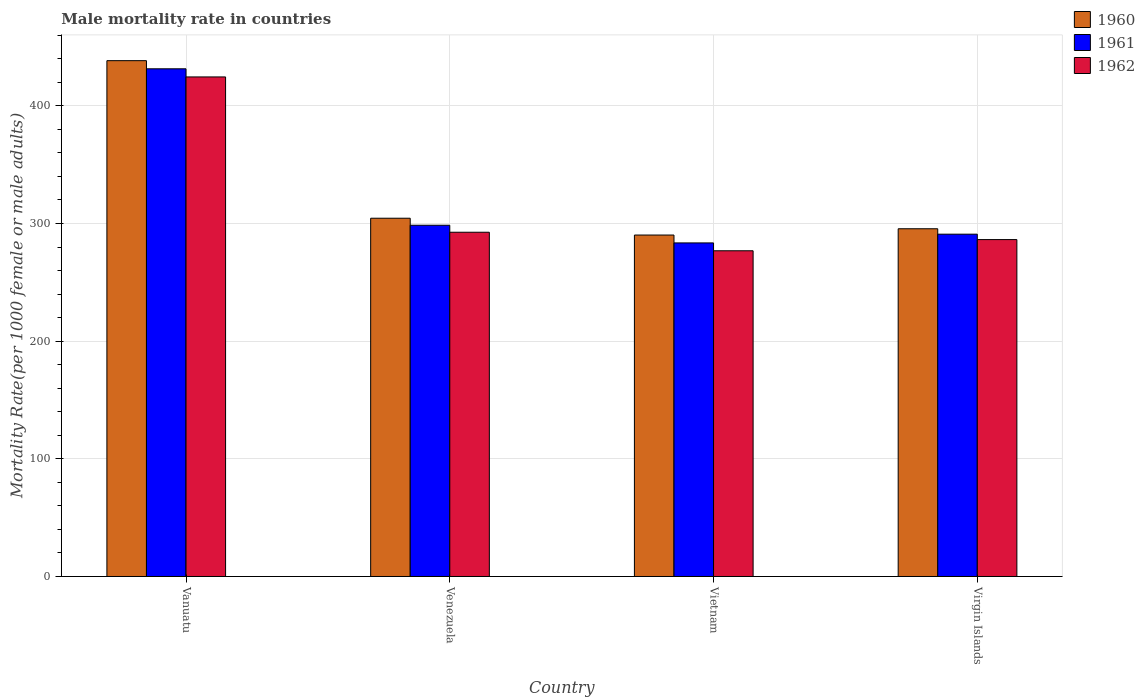How many groups of bars are there?
Ensure brevity in your answer.  4. Are the number of bars on each tick of the X-axis equal?
Your response must be concise. Yes. How many bars are there on the 1st tick from the left?
Provide a short and direct response. 3. How many bars are there on the 1st tick from the right?
Provide a short and direct response. 3. What is the label of the 1st group of bars from the left?
Your answer should be compact. Vanuatu. In how many cases, is the number of bars for a given country not equal to the number of legend labels?
Keep it short and to the point. 0. What is the male mortality rate in 1961 in Vietnam?
Offer a terse response. 283.51. Across all countries, what is the maximum male mortality rate in 1961?
Your response must be concise. 431.48. Across all countries, what is the minimum male mortality rate in 1961?
Make the answer very short. 283.51. In which country was the male mortality rate in 1962 maximum?
Give a very brief answer. Vanuatu. In which country was the male mortality rate in 1960 minimum?
Keep it short and to the point. Vietnam. What is the total male mortality rate in 1960 in the graph?
Make the answer very short. 1328.61. What is the difference between the male mortality rate in 1960 in Venezuela and that in Virgin Islands?
Your answer should be compact. 8.95. What is the difference between the male mortality rate in 1960 in Venezuela and the male mortality rate in 1962 in Vietnam?
Give a very brief answer. 27.66. What is the average male mortality rate in 1961 per country?
Your answer should be compact. 326.11. What is the difference between the male mortality rate of/in 1961 and male mortality rate of/in 1960 in Vietnam?
Offer a terse response. -6.69. In how many countries, is the male mortality rate in 1961 greater than 240?
Provide a succinct answer. 4. What is the ratio of the male mortality rate in 1962 in Vanuatu to that in Venezuela?
Your answer should be very brief. 1.45. Is the male mortality rate in 1960 in Vietnam less than that in Virgin Islands?
Ensure brevity in your answer.  Yes. What is the difference between the highest and the second highest male mortality rate in 1960?
Make the answer very short. -133.91. What is the difference between the highest and the lowest male mortality rate in 1960?
Keep it short and to the point. 148.2. In how many countries, is the male mortality rate in 1961 greater than the average male mortality rate in 1961 taken over all countries?
Ensure brevity in your answer.  1. What does the 3rd bar from the left in Venezuela represents?
Make the answer very short. 1962. What does the 3rd bar from the right in Venezuela represents?
Provide a short and direct response. 1960. What is the difference between two consecutive major ticks on the Y-axis?
Your answer should be compact. 100. Does the graph contain any zero values?
Make the answer very short. No. Where does the legend appear in the graph?
Provide a succinct answer. Top right. How many legend labels are there?
Offer a terse response. 3. How are the legend labels stacked?
Keep it short and to the point. Vertical. What is the title of the graph?
Provide a succinct answer. Male mortality rate in countries. Does "2013" appear as one of the legend labels in the graph?
Provide a short and direct response. No. What is the label or title of the X-axis?
Give a very brief answer. Country. What is the label or title of the Y-axis?
Ensure brevity in your answer.  Mortality Rate(per 1000 female or male adults). What is the Mortality Rate(per 1000 female or male adults) of 1960 in Vanuatu?
Provide a succinct answer. 438.4. What is the Mortality Rate(per 1000 female or male adults) in 1961 in Vanuatu?
Your response must be concise. 431.48. What is the Mortality Rate(per 1000 female or male adults) of 1962 in Vanuatu?
Give a very brief answer. 424.57. What is the Mortality Rate(per 1000 female or male adults) of 1960 in Venezuela?
Give a very brief answer. 304.49. What is the Mortality Rate(per 1000 female or male adults) in 1961 in Venezuela?
Give a very brief answer. 298.53. What is the Mortality Rate(per 1000 female or male adults) in 1962 in Venezuela?
Give a very brief answer. 292.57. What is the Mortality Rate(per 1000 female or male adults) of 1960 in Vietnam?
Your answer should be compact. 290.19. What is the Mortality Rate(per 1000 female or male adults) in 1961 in Vietnam?
Offer a terse response. 283.51. What is the Mortality Rate(per 1000 female or male adults) in 1962 in Vietnam?
Your answer should be very brief. 276.82. What is the Mortality Rate(per 1000 female or male adults) of 1960 in Virgin Islands?
Provide a short and direct response. 295.53. What is the Mortality Rate(per 1000 female or male adults) of 1961 in Virgin Islands?
Give a very brief answer. 290.94. What is the Mortality Rate(per 1000 female or male adults) of 1962 in Virgin Islands?
Keep it short and to the point. 286.34. Across all countries, what is the maximum Mortality Rate(per 1000 female or male adults) of 1960?
Give a very brief answer. 438.4. Across all countries, what is the maximum Mortality Rate(per 1000 female or male adults) of 1961?
Your answer should be very brief. 431.48. Across all countries, what is the maximum Mortality Rate(per 1000 female or male adults) in 1962?
Make the answer very short. 424.57. Across all countries, what is the minimum Mortality Rate(per 1000 female or male adults) of 1960?
Your response must be concise. 290.19. Across all countries, what is the minimum Mortality Rate(per 1000 female or male adults) in 1961?
Keep it short and to the point. 283.51. Across all countries, what is the minimum Mortality Rate(per 1000 female or male adults) of 1962?
Your answer should be very brief. 276.82. What is the total Mortality Rate(per 1000 female or male adults) in 1960 in the graph?
Your answer should be very brief. 1328.61. What is the total Mortality Rate(per 1000 female or male adults) in 1961 in the graph?
Keep it short and to the point. 1304.46. What is the total Mortality Rate(per 1000 female or male adults) in 1962 in the graph?
Make the answer very short. 1280.3. What is the difference between the Mortality Rate(per 1000 female or male adults) of 1960 in Vanuatu and that in Venezuela?
Make the answer very short. 133.91. What is the difference between the Mortality Rate(per 1000 female or male adults) of 1961 in Vanuatu and that in Venezuela?
Offer a terse response. 132.96. What is the difference between the Mortality Rate(per 1000 female or male adults) in 1962 in Vanuatu and that in Venezuela?
Provide a succinct answer. 132. What is the difference between the Mortality Rate(per 1000 female or male adults) in 1960 in Vanuatu and that in Vietnam?
Offer a very short reply. 148.2. What is the difference between the Mortality Rate(per 1000 female or male adults) of 1961 in Vanuatu and that in Vietnam?
Give a very brief answer. 147.97. What is the difference between the Mortality Rate(per 1000 female or male adults) in 1962 in Vanuatu and that in Vietnam?
Offer a very short reply. 147.75. What is the difference between the Mortality Rate(per 1000 female or male adults) in 1960 in Vanuatu and that in Virgin Islands?
Provide a succinct answer. 142.86. What is the difference between the Mortality Rate(per 1000 female or male adults) of 1961 in Vanuatu and that in Virgin Islands?
Give a very brief answer. 140.55. What is the difference between the Mortality Rate(per 1000 female or male adults) in 1962 in Vanuatu and that in Virgin Islands?
Make the answer very short. 138.23. What is the difference between the Mortality Rate(per 1000 female or male adults) in 1960 in Venezuela and that in Vietnam?
Your response must be concise. 14.29. What is the difference between the Mortality Rate(per 1000 female or male adults) of 1961 in Venezuela and that in Vietnam?
Give a very brief answer. 15.02. What is the difference between the Mortality Rate(per 1000 female or male adults) of 1962 in Venezuela and that in Vietnam?
Ensure brevity in your answer.  15.74. What is the difference between the Mortality Rate(per 1000 female or male adults) in 1960 in Venezuela and that in Virgin Islands?
Give a very brief answer. 8.95. What is the difference between the Mortality Rate(per 1000 female or male adults) in 1961 in Venezuela and that in Virgin Islands?
Keep it short and to the point. 7.59. What is the difference between the Mortality Rate(per 1000 female or male adults) of 1962 in Venezuela and that in Virgin Islands?
Offer a very short reply. 6.23. What is the difference between the Mortality Rate(per 1000 female or male adults) of 1960 in Vietnam and that in Virgin Islands?
Give a very brief answer. -5.34. What is the difference between the Mortality Rate(per 1000 female or male adults) of 1961 in Vietnam and that in Virgin Islands?
Offer a terse response. -7.43. What is the difference between the Mortality Rate(per 1000 female or male adults) in 1962 in Vietnam and that in Virgin Islands?
Provide a short and direct response. -9.51. What is the difference between the Mortality Rate(per 1000 female or male adults) in 1960 in Vanuatu and the Mortality Rate(per 1000 female or male adults) in 1961 in Venezuela?
Give a very brief answer. 139.87. What is the difference between the Mortality Rate(per 1000 female or male adults) in 1960 in Vanuatu and the Mortality Rate(per 1000 female or male adults) in 1962 in Venezuela?
Give a very brief answer. 145.83. What is the difference between the Mortality Rate(per 1000 female or male adults) in 1961 in Vanuatu and the Mortality Rate(per 1000 female or male adults) in 1962 in Venezuela?
Make the answer very short. 138.91. What is the difference between the Mortality Rate(per 1000 female or male adults) of 1960 in Vanuatu and the Mortality Rate(per 1000 female or male adults) of 1961 in Vietnam?
Your response must be concise. 154.89. What is the difference between the Mortality Rate(per 1000 female or male adults) in 1960 in Vanuatu and the Mortality Rate(per 1000 female or male adults) in 1962 in Vietnam?
Your response must be concise. 161.57. What is the difference between the Mortality Rate(per 1000 female or male adults) in 1961 in Vanuatu and the Mortality Rate(per 1000 female or male adults) in 1962 in Vietnam?
Provide a short and direct response. 154.66. What is the difference between the Mortality Rate(per 1000 female or male adults) of 1960 in Vanuatu and the Mortality Rate(per 1000 female or male adults) of 1961 in Virgin Islands?
Ensure brevity in your answer.  147.46. What is the difference between the Mortality Rate(per 1000 female or male adults) in 1960 in Vanuatu and the Mortality Rate(per 1000 female or male adults) in 1962 in Virgin Islands?
Your response must be concise. 152.06. What is the difference between the Mortality Rate(per 1000 female or male adults) in 1961 in Vanuatu and the Mortality Rate(per 1000 female or male adults) in 1962 in Virgin Islands?
Make the answer very short. 145.15. What is the difference between the Mortality Rate(per 1000 female or male adults) in 1960 in Venezuela and the Mortality Rate(per 1000 female or male adults) in 1961 in Vietnam?
Ensure brevity in your answer.  20.98. What is the difference between the Mortality Rate(per 1000 female or male adults) of 1960 in Venezuela and the Mortality Rate(per 1000 female or male adults) of 1962 in Vietnam?
Your answer should be compact. 27.66. What is the difference between the Mortality Rate(per 1000 female or male adults) in 1961 in Venezuela and the Mortality Rate(per 1000 female or male adults) in 1962 in Vietnam?
Give a very brief answer. 21.7. What is the difference between the Mortality Rate(per 1000 female or male adults) of 1960 in Venezuela and the Mortality Rate(per 1000 female or male adults) of 1961 in Virgin Islands?
Your answer should be compact. 13.55. What is the difference between the Mortality Rate(per 1000 female or male adults) of 1960 in Venezuela and the Mortality Rate(per 1000 female or male adults) of 1962 in Virgin Islands?
Provide a short and direct response. 18.15. What is the difference between the Mortality Rate(per 1000 female or male adults) in 1961 in Venezuela and the Mortality Rate(per 1000 female or male adults) in 1962 in Virgin Islands?
Provide a succinct answer. 12.19. What is the difference between the Mortality Rate(per 1000 female or male adults) of 1960 in Vietnam and the Mortality Rate(per 1000 female or male adults) of 1961 in Virgin Islands?
Provide a short and direct response. -0.74. What is the difference between the Mortality Rate(per 1000 female or male adults) of 1960 in Vietnam and the Mortality Rate(per 1000 female or male adults) of 1962 in Virgin Islands?
Offer a very short reply. 3.86. What is the difference between the Mortality Rate(per 1000 female or male adults) in 1961 in Vietnam and the Mortality Rate(per 1000 female or male adults) in 1962 in Virgin Islands?
Your answer should be compact. -2.83. What is the average Mortality Rate(per 1000 female or male adults) in 1960 per country?
Provide a succinct answer. 332.15. What is the average Mortality Rate(per 1000 female or male adults) of 1961 per country?
Your answer should be very brief. 326.11. What is the average Mortality Rate(per 1000 female or male adults) in 1962 per country?
Ensure brevity in your answer.  320.07. What is the difference between the Mortality Rate(per 1000 female or male adults) of 1960 and Mortality Rate(per 1000 female or male adults) of 1961 in Vanuatu?
Provide a short and direct response. 6.91. What is the difference between the Mortality Rate(per 1000 female or male adults) in 1960 and Mortality Rate(per 1000 female or male adults) in 1962 in Vanuatu?
Provide a short and direct response. 13.83. What is the difference between the Mortality Rate(per 1000 female or male adults) in 1961 and Mortality Rate(per 1000 female or male adults) in 1962 in Vanuatu?
Offer a very short reply. 6.91. What is the difference between the Mortality Rate(per 1000 female or male adults) of 1960 and Mortality Rate(per 1000 female or male adults) of 1961 in Venezuela?
Your answer should be compact. 5.96. What is the difference between the Mortality Rate(per 1000 female or male adults) in 1960 and Mortality Rate(per 1000 female or male adults) in 1962 in Venezuela?
Your answer should be compact. 11.92. What is the difference between the Mortality Rate(per 1000 female or male adults) of 1961 and Mortality Rate(per 1000 female or male adults) of 1962 in Venezuela?
Offer a very short reply. 5.96. What is the difference between the Mortality Rate(per 1000 female or male adults) of 1960 and Mortality Rate(per 1000 female or male adults) of 1961 in Vietnam?
Your response must be concise. 6.68. What is the difference between the Mortality Rate(per 1000 female or male adults) in 1960 and Mortality Rate(per 1000 female or male adults) in 1962 in Vietnam?
Make the answer very short. 13.37. What is the difference between the Mortality Rate(per 1000 female or male adults) in 1961 and Mortality Rate(per 1000 female or male adults) in 1962 in Vietnam?
Provide a short and direct response. 6.68. What is the difference between the Mortality Rate(per 1000 female or male adults) of 1960 and Mortality Rate(per 1000 female or male adults) of 1961 in Virgin Islands?
Ensure brevity in your answer.  4.6. What is the difference between the Mortality Rate(per 1000 female or male adults) of 1960 and Mortality Rate(per 1000 female or male adults) of 1962 in Virgin Islands?
Offer a very short reply. 9.2. What is the difference between the Mortality Rate(per 1000 female or male adults) in 1961 and Mortality Rate(per 1000 female or male adults) in 1962 in Virgin Islands?
Ensure brevity in your answer.  4.6. What is the ratio of the Mortality Rate(per 1000 female or male adults) in 1960 in Vanuatu to that in Venezuela?
Keep it short and to the point. 1.44. What is the ratio of the Mortality Rate(per 1000 female or male adults) of 1961 in Vanuatu to that in Venezuela?
Ensure brevity in your answer.  1.45. What is the ratio of the Mortality Rate(per 1000 female or male adults) in 1962 in Vanuatu to that in Venezuela?
Offer a very short reply. 1.45. What is the ratio of the Mortality Rate(per 1000 female or male adults) in 1960 in Vanuatu to that in Vietnam?
Your answer should be very brief. 1.51. What is the ratio of the Mortality Rate(per 1000 female or male adults) in 1961 in Vanuatu to that in Vietnam?
Your answer should be very brief. 1.52. What is the ratio of the Mortality Rate(per 1000 female or male adults) of 1962 in Vanuatu to that in Vietnam?
Your answer should be compact. 1.53. What is the ratio of the Mortality Rate(per 1000 female or male adults) of 1960 in Vanuatu to that in Virgin Islands?
Your response must be concise. 1.48. What is the ratio of the Mortality Rate(per 1000 female or male adults) of 1961 in Vanuatu to that in Virgin Islands?
Offer a very short reply. 1.48. What is the ratio of the Mortality Rate(per 1000 female or male adults) of 1962 in Vanuatu to that in Virgin Islands?
Provide a succinct answer. 1.48. What is the ratio of the Mortality Rate(per 1000 female or male adults) in 1960 in Venezuela to that in Vietnam?
Your response must be concise. 1.05. What is the ratio of the Mortality Rate(per 1000 female or male adults) in 1961 in Venezuela to that in Vietnam?
Keep it short and to the point. 1.05. What is the ratio of the Mortality Rate(per 1000 female or male adults) in 1962 in Venezuela to that in Vietnam?
Provide a short and direct response. 1.06. What is the ratio of the Mortality Rate(per 1000 female or male adults) in 1960 in Venezuela to that in Virgin Islands?
Offer a terse response. 1.03. What is the ratio of the Mortality Rate(per 1000 female or male adults) of 1961 in Venezuela to that in Virgin Islands?
Offer a terse response. 1.03. What is the ratio of the Mortality Rate(per 1000 female or male adults) in 1962 in Venezuela to that in Virgin Islands?
Give a very brief answer. 1.02. What is the ratio of the Mortality Rate(per 1000 female or male adults) in 1960 in Vietnam to that in Virgin Islands?
Provide a short and direct response. 0.98. What is the ratio of the Mortality Rate(per 1000 female or male adults) of 1961 in Vietnam to that in Virgin Islands?
Your answer should be very brief. 0.97. What is the ratio of the Mortality Rate(per 1000 female or male adults) of 1962 in Vietnam to that in Virgin Islands?
Provide a succinct answer. 0.97. What is the difference between the highest and the second highest Mortality Rate(per 1000 female or male adults) in 1960?
Offer a very short reply. 133.91. What is the difference between the highest and the second highest Mortality Rate(per 1000 female or male adults) in 1961?
Your response must be concise. 132.96. What is the difference between the highest and the second highest Mortality Rate(per 1000 female or male adults) in 1962?
Your response must be concise. 132. What is the difference between the highest and the lowest Mortality Rate(per 1000 female or male adults) of 1960?
Your answer should be compact. 148.2. What is the difference between the highest and the lowest Mortality Rate(per 1000 female or male adults) of 1961?
Ensure brevity in your answer.  147.97. What is the difference between the highest and the lowest Mortality Rate(per 1000 female or male adults) in 1962?
Provide a short and direct response. 147.75. 